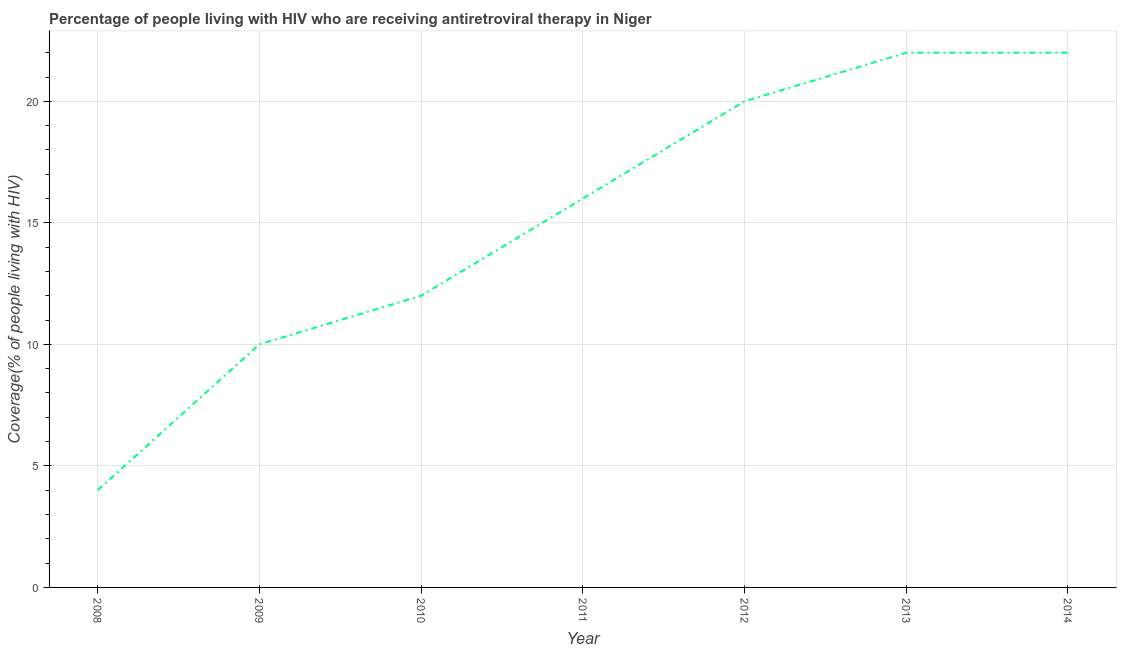What is the antiretroviral therapy coverage in 2012?
Offer a very short reply. 20. Across all years, what is the maximum antiretroviral therapy coverage?
Provide a succinct answer. 22. Across all years, what is the minimum antiretroviral therapy coverage?
Keep it short and to the point. 4. In which year was the antiretroviral therapy coverage minimum?
Your answer should be compact. 2008. What is the sum of the antiretroviral therapy coverage?
Provide a short and direct response. 106. What is the difference between the antiretroviral therapy coverage in 2010 and 2011?
Provide a succinct answer. -4. What is the average antiretroviral therapy coverage per year?
Offer a very short reply. 15.14. What is the median antiretroviral therapy coverage?
Provide a short and direct response. 16. What is the ratio of the antiretroviral therapy coverage in 2009 to that in 2011?
Your response must be concise. 0.62. Is the difference between the antiretroviral therapy coverage in 2009 and 2014 greater than the difference between any two years?
Provide a short and direct response. No. What is the difference between the highest and the lowest antiretroviral therapy coverage?
Your response must be concise. 18. Does the antiretroviral therapy coverage monotonically increase over the years?
Provide a succinct answer. No. How many years are there in the graph?
Provide a short and direct response. 7. What is the title of the graph?
Make the answer very short. Percentage of people living with HIV who are receiving antiretroviral therapy in Niger. What is the label or title of the Y-axis?
Your response must be concise. Coverage(% of people living with HIV). What is the Coverage(% of people living with HIV) of 2012?
Offer a terse response. 20. What is the Coverage(% of people living with HIV) of 2014?
Offer a very short reply. 22. What is the difference between the Coverage(% of people living with HIV) in 2008 and 2010?
Give a very brief answer. -8. What is the difference between the Coverage(% of people living with HIV) in 2008 and 2013?
Your response must be concise. -18. What is the difference between the Coverage(% of people living with HIV) in 2009 and 2011?
Your response must be concise. -6. What is the difference between the Coverage(% of people living with HIV) in 2009 and 2013?
Keep it short and to the point. -12. What is the difference between the Coverage(% of people living with HIV) in 2010 and 2011?
Keep it short and to the point. -4. What is the difference between the Coverage(% of people living with HIV) in 2010 and 2012?
Offer a terse response. -8. What is the difference between the Coverage(% of people living with HIV) in 2011 and 2013?
Your answer should be compact. -6. What is the difference between the Coverage(% of people living with HIV) in 2012 and 2013?
Your answer should be very brief. -2. What is the difference between the Coverage(% of people living with HIV) in 2012 and 2014?
Your response must be concise. -2. What is the difference between the Coverage(% of people living with HIV) in 2013 and 2014?
Offer a terse response. 0. What is the ratio of the Coverage(% of people living with HIV) in 2008 to that in 2010?
Offer a terse response. 0.33. What is the ratio of the Coverage(% of people living with HIV) in 2008 to that in 2011?
Ensure brevity in your answer.  0.25. What is the ratio of the Coverage(% of people living with HIV) in 2008 to that in 2012?
Provide a succinct answer. 0.2. What is the ratio of the Coverage(% of people living with HIV) in 2008 to that in 2013?
Your response must be concise. 0.18. What is the ratio of the Coverage(% of people living with HIV) in 2008 to that in 2014?
Make the answer very short. 0.18. What is the ratio of the Coverage(% of people living with HIV) in 2009 to that in 2010?
Offer a very short reply. 0.83. What is the ratio of the Coverage(% of people living with HIV) in 2009 to that in 2012?
Your answer should be very brief. 0.5. What is the ratio of the Coverage(% of people living with HIV) in 2009 to that in 2013?
Provide a short and direct response. 0.46. What is the ratio of the Coverage(% of people living with HIV) in 2009 to that in 2014?
Make the answer very short. 0.46. What is the ratio of the Coverage(% of people living with HIV) in 2010 to that in 2011?
Ensure brevity in your answer.  0.75. What is the ratio of the Coverage(% of people living with HIV) in 2010 to that in 2012?
Ensure brevity in your answer.  0.6. What is the ratio of the Coverage(% of people living with HIV) in 2010 to that in 2013?
Your answer should be compact. 0.55. What is the ratio of the Coverage(% of people living with HIV) in 2010 to that in 2014?
Your response must be concise. 0.55. What is the ratio of the Coverage(% of people living with HIV) in 2011 to that in 2013?
Give a very brief answer. 0.73. What is the ratio of the Coverage(% of people living with HIV) in 2011 to that in 2014?
Offer a very short reply. 0.73. What is the ratio of the Coverage(% of people living with HIV) in 2012 to that in 2013?
Offer a terse response. 0.91. What is the ratio of the Coverage(% of people living with HIV) in 2012 to that in 2014?
Make the answer very short. 0.91. 